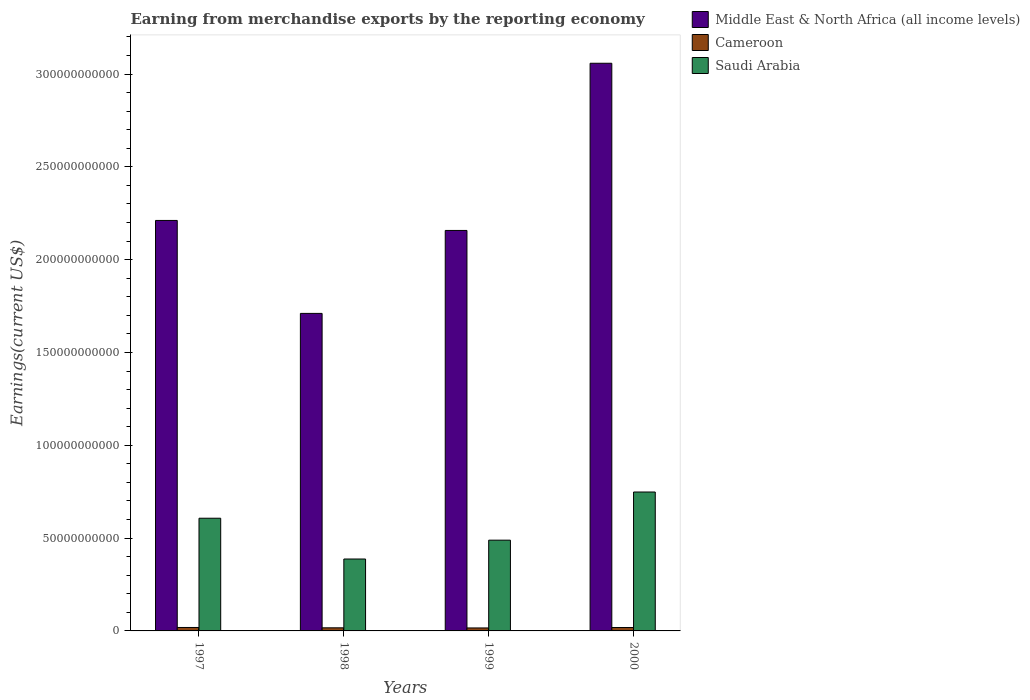How many groups of bars are there?
Keep it short and to the point. 4. Are the number of bars on each tick of the X-axis equal?
Offer a very short reply. Yes. How many bars are there on the 2nd tick from the left?
Give a very brief answer. 3. What is the label of the 2nd group of bars from the left?
Ensure brevity in your answer.  1998. What is the amount earned from merchandise exports in Middle East & North Africa (all income levels) in 1998?
Keep it short and to the point. 1.71e+11. Across all years, what is the maximum amount earned from merchandise exports in Middle East & North Africa (all income levels)?
Your answer should be compact. 3.06e+11. Across all years, what is the minimum amount earned from merchandise exports in Cameroon?
Make the answer very short. 1.60e+09. In which year was the amount earned from merchandise exports in Middle East & North Africa (all income levels) maximum?
Give a very brief answer. 2000. In which year was the amount earned from merchandise exports in Middle East & North Africa (all income levels) minimum?
Your answer should be very brief. 1998. What is the total amount earned from merchandise exports in Cameroon in the graph?
Give a very brief answer. 6.96e+09. What is the difference between the amount earned from merchandise exports in Saudi Arabia in 1998 and that in 1999?
Offer a terse response. -1.02e+1. What is the difference between the amount earned from merchandise exports in Saudi Arabia in 2000 and the amount earned from merchandise exports in Middle East & North Africa (all income levels) in 1998?
Offer a terse response. -9.62e+1. What is the average amount earned from merchandise exports in Middle East & North Africa (all income levels) per year?
Your answer should be very brief. 2.28e+11. In the year 1997, what is the difference between the amount earned from merchandise exports in Saudi Arabia and amount earned from merchandise exports in Middle East & North Africa (all income levels)?
Your answer should be very brief. -1.60e+11. What is the ratio of the amount earned from merchandise exports in Cameroon in 1997 to that in 1998?
Provide a short and direct response. 1.11. Is the amount earned from merchandise exports in Cameroon in 1998 less than that in 2000?
Keep it short and to the point. Yes. Is the difference between the amount earned from merchandise exports in Saudi Arabia in 1998 and 1999 greater than the difference between the amount earned from merchandise exports in Middle East & North Africa (all income levels) in 1998 and 1999?
Keep it short and to the point. Yes. What is the difference between the highest and the second highest amount earned from merchandise exports in Middle East & North Africa (all income levels)?
Offer a terse response. 8.47e+1. What is the difference between the highest and the lowest amount earned from merchandise exports in Middle East & North Africa (all income levels)?
Give a very brief answer. 1.35e+11. What does the 1st bar from the left in 1997 represents?
Make the answer very short. Middle East & North Africa (all income levels). What does the 3rd bar from the right in 1997 represents?
Provide a succinct answer. Middle East & North Africa (all income levels). Is it the case that in every year, the sum of the amount earned from merchandise exports in Cameroon and amount earned from merchandise exports in Middle East & North Africa (all income levels) is greater than the amount earned from merchandise exports in Saudi Arabia?
Give a very brief answer. Yes. How many bars are there?
Provide a short and direct response. 12. Are all the bars in the graph horizontal?
Provide a short and direct response. No. How many years are there in the graph?
Provide a short and direct response. 4. Are the values on the major ticks of Y-axis written in scientific E-notation?
Give a very brief answer. No. Does the graph contain grids?
Ensure brevity in your answer.  No. How are the legend labels stacked?
Offer a terse response. Vertical. What is the title of the graph?
Your answer should be very brief. Earning from merchandise exports by the reporting economy. Does "Rwanda" appear as one of the legend labels in the graph?
Keep it short and to the point. No. What is the label or title of the Y-axis?
Your answer should be compact. Earnings(current US$). What is the Earnings(current US$) of Middle East & North Africa (all income levels) in 1997?
Ensure brevity in your answer.  2.21e+11. What is the Earnings(current US$) of Cameroon in 1997?
Your answer should be compact. 1.86e+09. What is the Earnings(current US$) of Saudi Arabia in 1997?
Make the answer very short. 6.07e+1. What is the Earnings(current US$) of Middle East & North Africa (all income levels) in 1998?
Provide a succinct answer. 1.71e+11. What is the Earnings(current US$) in Cameroon in 1998?
Provide a short and direct response. 1.67e+09. What is the Earnings(current US$) in Saudi Arabia in 1998?
Give a very brief answer. 3.87e+1. What is the Earnings(current US$) of Middle East & North Africa (all income levels) in 1999?
Provide a short and direct response. 2.16e+11. What is the Earnings(current US$) in Cameroon in 1999?
Your answer should be very brief. 1.60e+09. What is the Earnings(current US$) in Saudi Arabia in 1999?
Offer a terse response. 4.89e+1. What is the Earnings(current US$) in Middle East & North Africa (all income levels) in 2000?
Keep it short and to the point. 3.06e+11. What is the Earnings(current US$) in Cameroon in 2000?
Make the answer very short. 1.83e+09. What is the Earnings(current US$) of Saudi Arabia in 2000?
Your response must be concise. 7.48e+1. Across all years, what is the maximum Earnings(current US$) in Middle East & North Africa (all income levels)?
Your response must be concise. 3.06e+11. Across all years, what is the maximum Earnings(current US$) in Cameroon?
Your answer should be very brief. 1.86e+09. Across all years, what is the maximum Earnings(current US$) in Saudi Arabia?
Provide a succinct answer. 7.48e+1. Across all years, what is the minimum Earnings(current US$) in Middle East & North Africa (all income levels)?
Ensure brevity in your answer.  1.71e+11. Across all years, what is the minimum Earnings(current US$) in Cameroon?
Give a very brief answer. 1.60e+09. Across all years, what is the minimum Earnings(current US$) of Saudi Arabia?
Your answer should be very brief. 3.87e+1. What is the total Earnings(current US$) in Middle East & North Africa (all income levels) in the graph?
Offer a very short reply. 9.14e+11. What is the total Earnings(current US$) of Cameroon in the graph?
Ensure brevity in your answer.  6.96e+09. What is the total Earnings(current US$) of Saudi Arabia in the graph?
Make the answer very short. 2.23e+11. What is the difference between the Earnings(current US$) of Middle East & North Africa (all income levels) in 1997 and that in 1998?
Provide a succinct answer. 5.01e+1. What is the difference between the Earnings(current US$) in Cameroon in 1997 and that in 1998?
Make the answer very short. 1.87e+08. What is the difference between the Earnings(current US$) in Saudi Arabia in 1997 and that in 1998?
Your answer should be compact. 2.20e+1. What is the difference between the Earnings(current US$) of Middle East & North Africa (all income levels) in 1997 and that in 1999?
Your answer should be very brief. 5.39e+09. What is the difference between the Earnings(current US$) of Cameroon in 1997 and that in 1999?
Keep it short and to the point. 2.57e+08. What is the difference between the Earnings(current US$) of Saudi Arabia in 1997 and that in 1999?
Make the answer very short. 1.18e+1. What is the difference between the Earnings(current US$) in Middle East & North Africa (all income levels) in 1997 and that in 2000?
Give a very brief answer. -8.47e+1. What is the difference between the Earnings(current US$) in Cameroon in 1997 and that in 2000?
Your answer should be compact. 2.57e+07. What is the difference between the Earnings(current US$) of Saudi Arabia in 1997 and that in 2000?
Your answer should be compact. -1.41e+1. What is the difference between the Earnings(current US$) in Middle East & North Africa (all income levels) in 1998 and that in 1999?
Ensure brevity in your answer.  -4.47e+1. What is the difference between the Earnings(current US$) in Cameroon in 1998 and that in 1999?
Provide a succinct answer. 7.04e+07. What is the difference between the Earnings(current US$) in Saudi Arabia in 1998 and that in 1999?
Give a very brief answer. -1.02e+1. What is the difference between the Earnings(current US$) of Middle East & North Africa (all income levels) in 1998 and that in 2000?
Provide a short and direct response. -1.35e+11. What is the difference between the Earnings(current US$) in Cameroon in 1998 and that in 2000?
Your response must be concise. -1.61e+08. What is the difference between the Earnings(current US$) of Saudi Arabia in 1998 and that in 2000?
Ensure brevity in your answer.  -3.61e+1. What is the difference between the Earnings(current US$) in Middle East & North Africa (all income levels) in 1999 and that in 2000?
Your answer should be compact. -9.01e+1. What is the difference between the Earnings(current US$) of Cameroon in 1999 and that in 2000?
Ensure brevity in your answer.  -2.32e+08. What is the difference between the Earnings(current US$) of Saudi Arabia in 1999 and that in 2000?
Give a very brief answer. -2.59e+1. What is the difference between the Earnings(current US$) in Middle East & North Africa (all income levels) in 1997 and the Earnings(current US$) in Cameroon in 1998?
Provide a short and direct response. 2.19e+11. What is the difference between the Earnings(current US$) of Middle East & North Africa (all income levels) in 1997 and the Earnings(current US$) of Saudi Arabia in 1998?
Provide a succinct answer. 1.82e+11. What is the difference between the Earnings(current US$) of Cameroon in 1997 and the Earnings(current US$) of Saudi Arabia in 1998?
Offer a terse response. -3.69e+1. What is the difference between the Earnings(current US$) in Middle East & North Africa (all income levels) in 1997 and the Earnings(current US$) in Cameroon in 1999?
Your response must be concise. 2.20e+11. What is the difference between the Earnings(current US$) of Middle East & North Africa (all income levels) in 1997 and the Earnings(current US$) of Saudi Arabia in 1999?
Your answer should be compact. 1.72e+11. What is the difference between the Earnings(current US$) of Cameroon in 1997 and the Earnings(current US$) of Saudi Arabia in 1999?
Make the answer very short. -4.70e+1. What is the difference between the Earnings(current US$) of Middle East & North Africa (all income levels) in 1997 and the Earnings(current US$) of Cameroon in 2000?
Make the answer very short. 2.19e+11. What is the difference between the Earnings(current US$) of Middle East & North Africa (all income levels) in 1997 and the Earnings(current US$) of Saudi Arabia in 2000?
Your answer should be very brief. 1.46e+11. What is the difference between the Earnings(current US$) in Cameroon in 1997 and the Earnings(current US$) in Saudi Arabia in 2000?
Keep it short and to the point. -7.30e+1. What is the difference between the Earnings(current US$) in Middle East & North Africa (all income levels) in 1998 and the Earnings(current US$) in Cameroon in 1999?
Your response must be concise. 1.69e+11. What is the difference between the Earnings(current US$) of Middle East & North Africa (all income levels) in 1998 and the Earnings(current US$) of Saudi Arabia in 1999?
Make the answer very short. 1.22e+11. What is the difference between the Earnings(current US$) of Cameroon in 1998 and the Earnings(current US$) of Saudi Arabia in 1999?
Provide a succinct answer. -4.72e+1. What is the difference between the Earnings(current US$) in Middle East & North Africa (all income levels) in 1998 and the Earnings(current US$) in Cameroon in 2000?
Offer a terse response. 1.69e+11. What is the difference between the Earnings(current US$) of Middle East & North Africa (all income levels) in 1998 and the Earnings(current US$) of Saudi Arabia in 2000?
Your answer should be very brief. 9.62e+1. What is the difference between the Earnings(current US$) of Cameroon in 1998 and the Earnings(current US$) of Saudi Arabia in 2000?
Offer a terse response. -7.32e+1. What is the difference between the Earnings(current US$) of Middle East & North Africa (all income levels) in 1999 and the Earnings(current US$) of Cameroon in 2000?
Keep it short and to the point. 2.14e+11. What is the difference between the Earnings(current US$) of Middle East & North Africa (all income levels) in 1999 and the Earnings(current US$) of Saudi Arabia in 2000?
Provide a short and direct response. 1.41e+11. What is the difference between the Earnings(current US$) of Cameroon in 1999 and the Earnings(current US$) of Saudi Arabia in 2000?
Give a very brief answer. -7.32e+1. What is the average Earnings(current US$) of Middle East & North Africa (all income levels) per year?
Your response must be concise. 2.28e+11. What is the average Earnings(current US$) in Cameroon per year?
Keep it short and to the point. 1.74e+09. What is the average Earnings(current US$) of Saudi Arabia per year?
Your answer should be very brief. 5.58e+1. In the year 1997, what is the difference between the Earnings(current US$) of Middle East & North Africa (all income levels) and Earnings(current US$) of Cameroon?
Your answer should be very brief. 2.19e+11. In the year 1997, what is the difference between the Earnings(current US$) of Middle East & North Africa (all income levels) and Earnings(current US$) of Saudi Arabia?
Make the answer very short. 1.60e+11. In the year 1997, what is the difference between the Earnings(current US$) in Cameroon and Earnings(current US$) in Saudi Arabia?
Make the answer very short. -5.88e+1. In the year 1998, what is the difference between the Earnings(current US$) of Middle East & North Africa (all income levels) and Earnings(current US$) of Cameroon?
Provide a succinct answer. 1.69e+11. In the year 1998, what is the difference between the Earnings(current US$) in Middle East & North Africa (all income levels) and Earnings(current US$) in Saudi Arabia?
Your response must be concise. 1.32e+11. In the year 1998, what is the difference between the Earnings(current US$) of Cameroon and Earnings(current US$) of Saudi Arabia?
Your response must be concise. -3.71e+1. In the year 1999, what is the difference between the Earnings(current US$) in Middle East & North Africa (all income levels) and Earnings(current US$) in Cameroon?
Your response must be concise. 2.14e+11. In the year 1999, what is the difference between the Earnings(current US$) of Middle East & North Africa (all income levels) and Earnings(current US$) of Saudi Arabia?
Your response must be concise. 1.67e+11. In the year 1999, what is the difference between the Earnings(current US$) in Cameroon and Earnings(current US$) in Saudi Arabia?
Keep it short and to the point. -4.73e+1. In the year 2000, what is the difference between the Earnings(current US$) of Middle East & North Africa (all income levels) and Earnings(current US$) of Cameroon?
Make the answer very short. 3.04e+11. In the year 2000, what is the difference between the Earnings(current US$) in Middle East & North Africa (all income levels) and Earnings(current US$) in Saudi Arabia?
Offer a very short reply. 2.31e+11. In the year 2000, what is the difference between the Earnings(current US$) in Cameroon and Earnings(current US$) in Saudi Arabia?
Keep it short and to the point. -7.30e+1. What is the ratio of the Earnings(current US$) in Middle East & North Africa (all income levels) in 1997 to that in 1998?
Your answer should be compact. 1.29. What is the ratio of the Earnings(current US$) of Cameroon in 1997 to that in 1998?
Provide a short and direct response. 1.11. What is the ratio of the Earnings(current US$) in Saudi Arabia in 1997 to that in 1998?
Offer a terse response. 1.57. What is the ratio of the Earnings(current US$) of Middle East & North Africa (all income levels) in 1997 to that in 1999?
Your answer should be compact. 1.02. What is the ratio of the Earnings(current US$) of Cameroon in 1997 to that in 1999?
Offer a terse response. 1.16. What is the ratio of the Earnings(current US$) in Saudi Arabia in 1997 to that in 1999?
Provide a short and direct response. 1.24. What is the ratio of the Earnings(current US$) in Middle East & North Africa (all income levels) in 1997 to that in 2000?
Keep it short and to the point. 0.72. What is the ratio of the Earnings(current US$) of Cameroon in 1997 to that in 2000?
Ensure brevity in your answer.  1.01. What is the ratio of the Earnings(current US$) of Saudi Arabia in 1997 to that in 2000?
Your answer should be compact. 0.81. What is the ratio of the Earnings(current US$) in Middle East & North Africa (all income levels) in 1998 to that in 1999?
Keep it short and to the point. 0.79. What is the ratio of the Earnings(current US$) of Cameroon in 1998 to that in 1999?
Keep it short and to the point. 1.04. What is the ratio of the Earnings(current US$) of Saudi Arabia in 1998 to that in 1999?
Your answer should be compact. 0.79. What is the ratio of the Earnings(current US$) of Middle East & North Africa (all income levels) in 1998 to that in 2000?
Offer a very short reply. 0.56. What is the ratio of the Earnings(current US$) of Cameroon in 1998 to that in 2000?
Offer a terse response. 0.91. What is the ratio of the Earnings(current US$) of Saudi Arabia in 1998 to that in 2000?
Keep it short and to the point. 0.52. What is the ratio of the Earnings(current US$) of Middle East & North Africa (all income levels) in 1999 to that in 2000?
Your answer should be compact. 0.71. What is the ratio of the Earnings(current US$) in Cameroon in 1999 to that in 2000?
Give a very brief answer. 0.87. What is the ratio of the Earnings(current US$) in Saudi Arabia in 1999 to that in 2000?
Provide a succinct answer. 0.65. What is the difference between the highest and the second highest Earnings(current US$) of Middle East & North Africa (all income levels)?
Give a very brief answer. 8.47e+1. What is the difference between the highest and the second highest Earnings(current US$) in Cameroon?
Offer a very short reply. 2.57e+07. What is the difference between the highest and the second highest Earnings(current US$) of Saudi Arabia?
Your response must be concise. 1.41e+1. What is the difference between the highest and the lowest Earnings(current US$) in Middle East & North Africa (all income levels)?
Make the answer very short. 1.35e+11. What is the difference between the highest and the lowest Earnings(current US$) of Cameroon?
Your answer should be compact. 2.57e+08. What is the difference between the highest and the lowest Earnings(current US$) in Saudi Arabia?
Provide a succinct answer. 3.61e+1. 